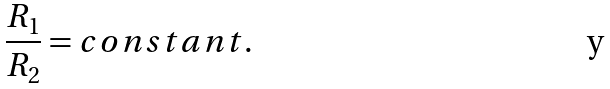<formula> <loc_0><loc_0><loc_500><loc_500>\frac { R _ { 1 } } { R _ { 2 } } = c o n s t a n t .</formula> 